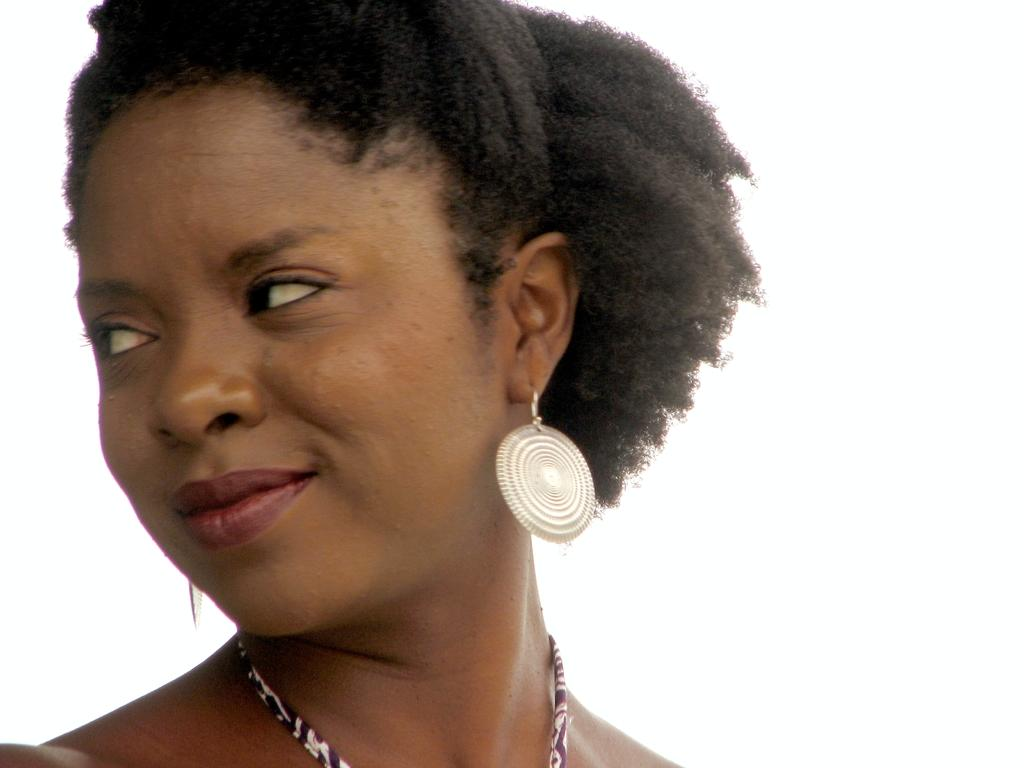Who is the main subject in the image? There is a lady in the image. What is the lady wearing around her neck? The lady is wearing a chain. What type of jewelry is the lady wearing on her ears? The lady is wearing earrings. What adjustment does the lady need to make to her level in the image? There is no indication in the image that the lady needs to make any adjustments to her level. 